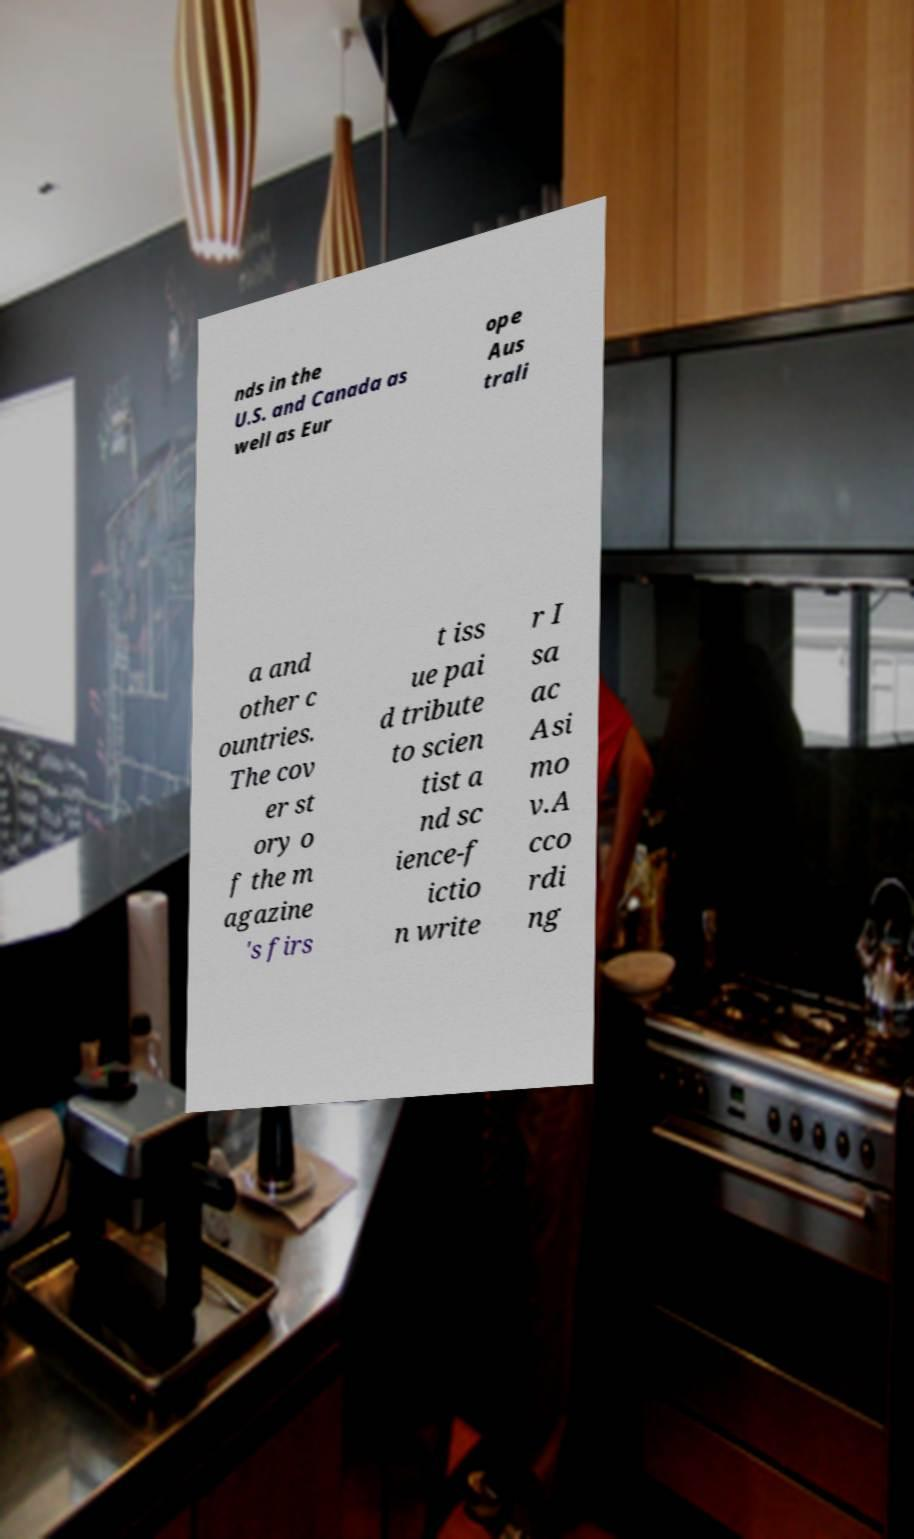Could you extract and type out the text from this image? nds in the U.S. and Canada as well as Eur ope Aus trali a and other c ountries. The cov er st ory o f the m agazine 's firs t iss ue pai d tribute to scien tist a nd sc ience-f ictio n write r I sa ac Asi mo v.A cco rdi ng 